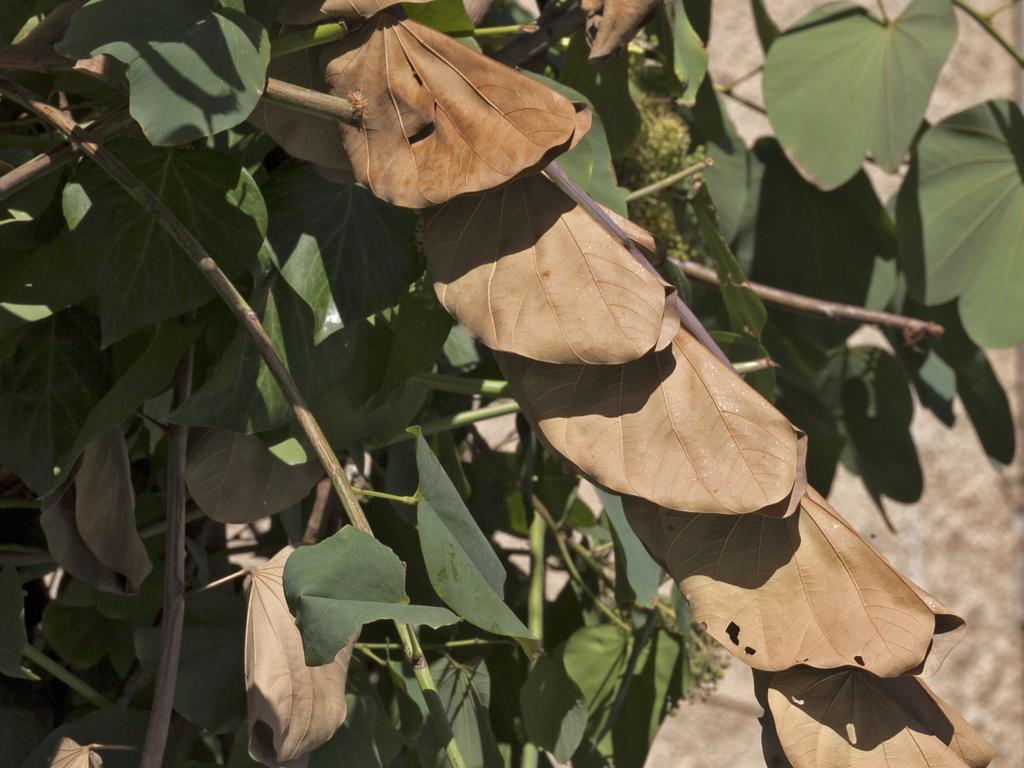What type of object is present in the image? There is a plant in the image. What color are the leaves of the plant? The plant has green leaves and brown leaves. What type of bridge can be seen in the image? There is no bridge present in the image; it features a plant with green and brown leaves. 